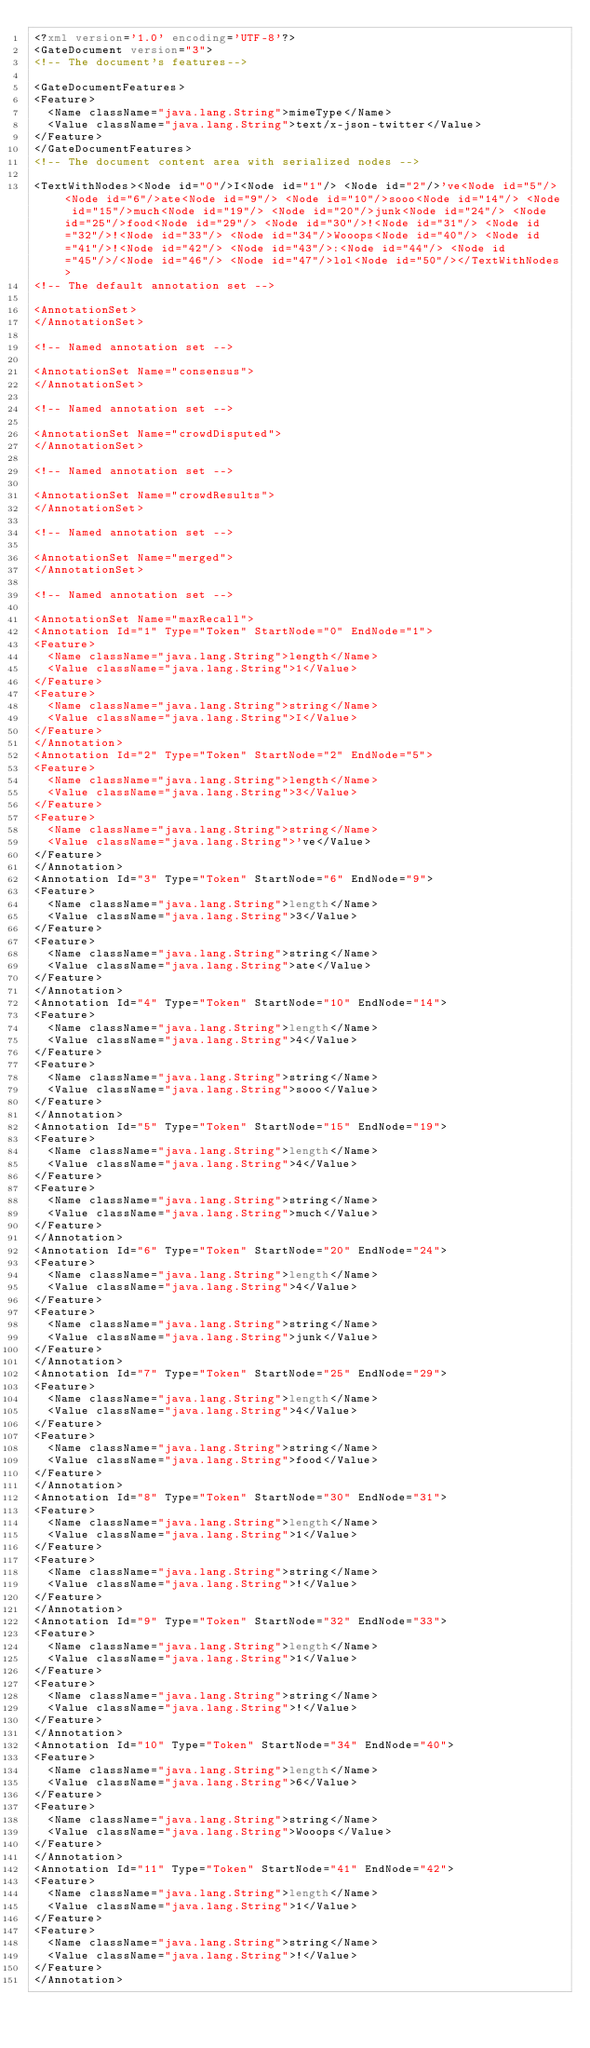Convert code to text. <code><loc_0><loc_0><loc_500><loc_500><_XML_><?xml version='1.0' encoding='UTF-8'?>
<GateDocument version="3">
<!-- The document's features-->

<GateDocumentFeatures>
<Feature>
  <Name className="java.lang.String">mimeType</Name>
  <Value className="java.lang.String">text/x-json-twitter</Value>
</Feature>
</GateDocumentFeatures>
<!-- The document content area with serialized nodes -->

<TextWithNodes><Node id="0"/>I<Node id="1"/> <Node id="2"/>'ve<Node id="5"/> <Node id="6"/>ate<Node id="9"/> <Node id="10"/>sooo<Node id="14"/> <Node id="15"/>much<Node id="19"/> <Node id="20"/>junk<Node id="24"/> <Node id="25"/>food<Node id="29"/> <Node id="30"/>!<Node id="31"/> <Node id="32"/>!<Node id="33"/> <Node id="34"/>Wooops<Node id="40"/> <Node id="41"/>!<Node id="42"/> <Node id="43"/>:<Node id="44"/> <Node id="45"/>/<Node id="46"/> <Node id="47"/>lol<Node id="50"/></TextWithNodes>
<!-- The default annotation set -->

<AnnotationSet>
</AnnotationSet>

<!-- Named annotation set -->

<AnnotationSet Name="consensus">
</AnnotationSet>

<!-- Named annotation set -->

<AnnotationSet Name="crowdDisputed">
</AnnotationSet>

<!-- Named annotation set -->

<AnnotationSet Name="crowdResults">
</AnnotationSet>

<!-- Named annotation set -->

<AnnotationSet Name="merged">
</AnnotationSet>

<!-- Named annotation set -->

<AnnotationSet Name="maxRecall">
<Annotation Id="1" Type="Token" StartNode="0" EndNode="1">
<Feature>
  <Name className="java.lang.String">length</Name>
  <Value className="java.lang.String">1</Value>
</Feature>
<Feature>
  <Name className="java.lang.String">string</Name>
  <Value className="java.lang.String">I</Value>
</Feature>
</Annotation>
<Annotation Id="2" Type="Token" StartNode="2" EndNode="5">
<Feature>
  <Name className="java.lang.String">length</Name>
  <Value className="java.lang.String">3</Value>
</Feature>
<Feature>
  <Name className="java.lang.String">string</Name>
  <Value className="java.lang.String">'ve</Value>
</Feature>
</Annotation>
<Annotation Id="3" Type="Token" StartNode="6" EndNode="9">
<Feature>
  <Name className="java.lang.String">length</Name>
  <Value className="java.lang.String">3</Value>
</Feature>
<Feature>
  <Name className="java.lang.String">string</Name>
  <Value className="java.lang.String">ate</Value>
</Feature>
</Annotation>
<Annotation Id="4" Type="Token" StartNode="10" EndNode="14">
<Feature>
  <Name className="java.lang.String">length</Name>
  <Value className="java.lang.String">4</Value>
</Feature>
<Feature>
  <Name className="java.lang.String">string</Name>
  <Value className="java.lang.String">sooo</Value>
</Feature>
</Annotation>
<Annotation Id="5" Type="Token" StartNode="15" EndNode="19">
<Feature>
  <Name className="java.lang.String">length</Name>
  <Value className="java.lang.String">4</Value>
</Feature>
<Feature>
  <Name className="java.lang.String">string</Name>
  <Value className="java.lang.String">much</Value>
</Feature>
</Annotation>
<Annotation Id="6" Type="Token" StartNode="20" EndNode="24">
<Feature>
  <Name className="java.lang.String">length</Name>
  <Value className="java.lang.String">4</Value>
</Feature>
<Feature>
  <Name className="java.lang.String">string</Name>
  <Value className="java.lang.String">junk</Value>
</Feature>
</Annotation>
<Annotation Id="7" Type="Token" StartNode="25" EndNode="29">
<Feature>
  <Name className="java.lang.String">length</Name>
  <Value className="java.lang.String">4</Value>
</Feature>
<Feature>
  <Name className="java.lang.String">string</Name>
  <Value className="java.lang.String">food</Value>
</Feature>
</Annotation>
<Annotation Id="8" Type="Token" StartNode="30" EndNode="31">
<Feature>
  <Name className="java.lang.String">length</Name>
  <Value className="java.lang.String">1</Value>
</Feature>
<Feature>
  <Name className="java.lang.String">string</Name>
  <Value className="java.lang.String">!</Value>
</Feature>
</Annotation>
<Annotation Id="9" Type="Token" StartNode="32" EndNode="33">
<Feature>
  <Name className="java.lang.String">length</Name>
  <Value className="java.lang.String">1</Value>
</Feature>
<Feature>
  <Name className="java.lang.String">string</Name>
  <Value className="java.lang.String">!</Value>
</Feature>
</Annotation>
<Annotation Id="10" Type="Token" StartNode="34" EndNode="40">
<Feature>
  <Name className="java.lang.String">length</Name>
  <Value className="java.lang.String">6</Value>
</Feature>
<Feature>
  <Name className="java.lang.String">string</Name>
  <Value className="java.lang.String">Wooops</Value>
</Feature>
</Annotation>
<Annotation Id="11" Type="Token" StartNode="41" EndNode="42">
<Feature>
  <Name className="java.lang.String">length</Name>
  <Value className="java.lang.String">1</Value>
</Feature>
<Feature>
  <Name className="java.lang.String">string</Name>
  <Value className="java.lang.String">!</Value>
</Feature>
</Annotation></code> 